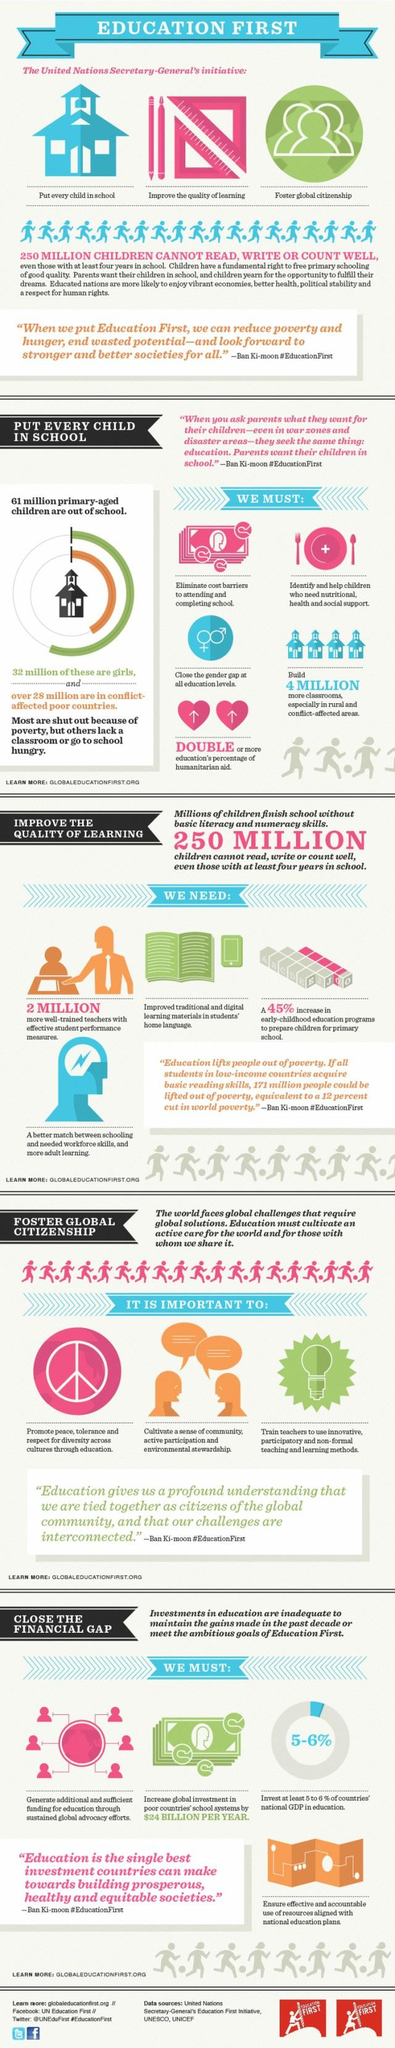Identify some key points in this picture. The name of the current UN Secretary-General is Ban Ki-moon. Ban Ki-moon, as an individual, has initiated several programs aimed at improving education for all children. These initiatives include working towards ensuring that every child receives a quality education, fostering global citizenship, and improving the quality of learning. In order to ensure access to quality education for all, sustained global advocacy efforts are essential, and additional and sufficient funding is required to support these efforts. It is estimated that 2 million well-trained teachers are required to address the current teacher shortage. The plate displays a sign that is indicative of a particular sign," the person stated. 